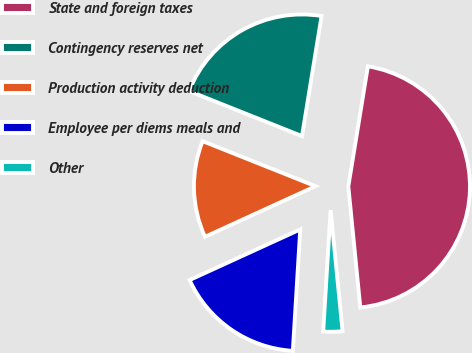Convert chart. <chart><loc_0><loc_0><loc_500><loc_500><pie_chart><fcel>State and foreign taxes<fcel>Contingency reserves net<fcel>Production activity deduction<fcel>Employee per diems meals and<fcel>Other<nl><fcel>45.86%<fcel>21.53%<fcel>12.87%<fcel>17.2%<fcel>2.54%<nl></chart> 